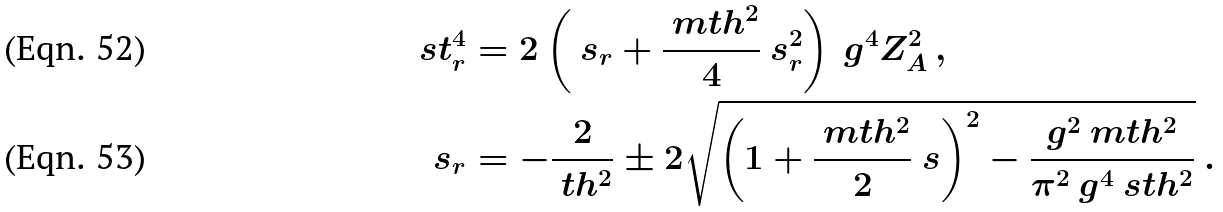<formula> <loc_0><loc_0><loc_500><loc_500>\ s t _ { r } ^ { 4 } & = 2 \left ( \ s _ { r } + \frac { \ m t h ^ { 2 } } { 4 } \ s _ { r } ^ { 2 } \right ) { \ g ^ { 4 } } { Z _ { A } ^ { 2 } } \, , \\ \ s _ { r } & = - \frac { 2 } { \ t h ^ { 2 } } \pm 2 \sqrt { \left ( 1 + \frac { \ m t h ^ { 2 } } { 2 } \ s \right ) ^ { 2 } - \frac { g ^ { 2 } \ m t h ^ { 2 } } { \pi ^ { 2 } \ g ^ { 4 } \ s t h ^ { 2 } } } \ .</formula> 